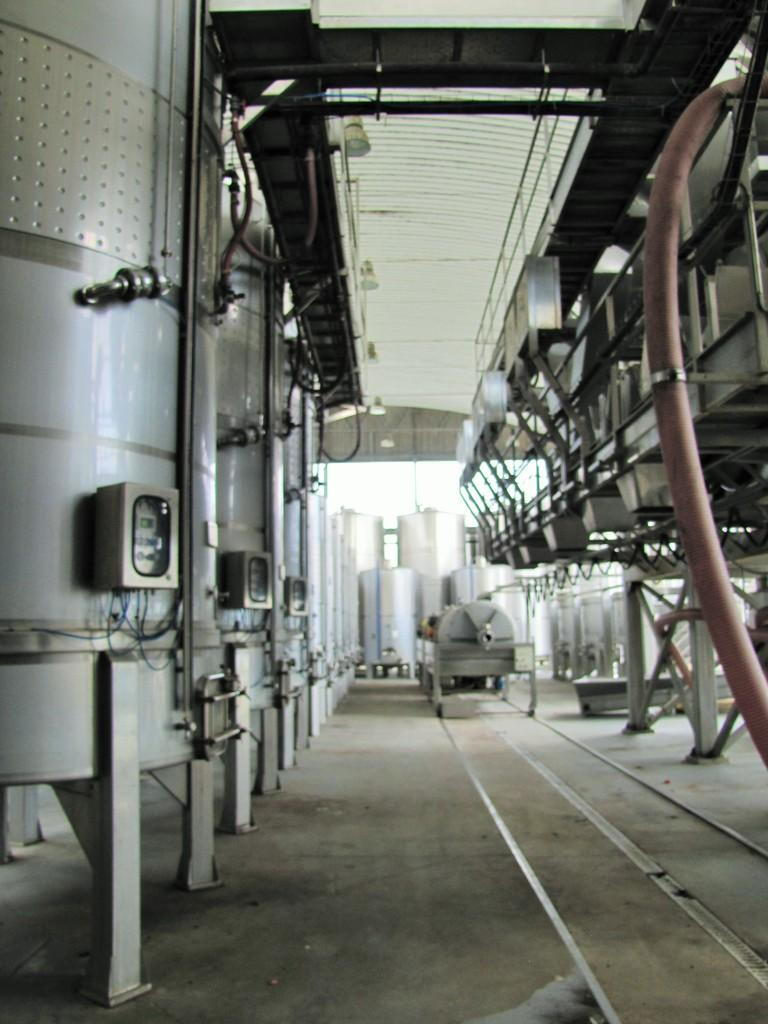What is the main subject of the image? The main subject of the image is many machines. Where are the machines located in relation to each other? The machines are on either side of a path. What type of bird can be seen bursting out of the machines in the image? There is no bird present in the image, and the machines are not depicted as bursting. 